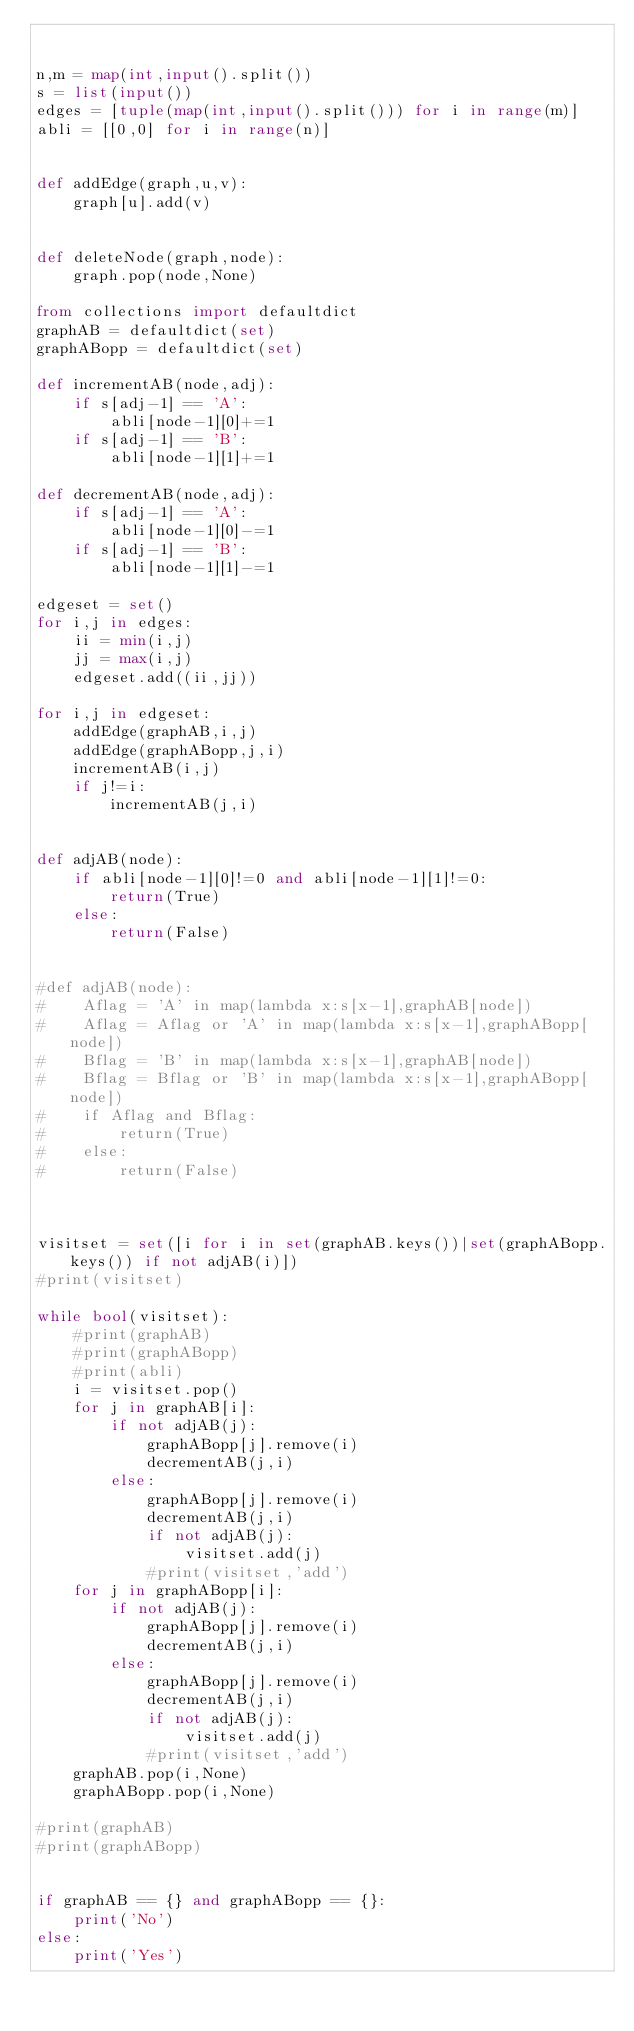Convert code to text. <code><loc_0><loc_0><loc_500><loc_500><_Python_>

n,m = map(int,input().split())
s = list(input())
edges = [tuple(map(int,input().split())) for i in range(m)]
abli = [[0,0] for i in range(n)]


def addEdge(graph,u,v):
    graph[u].add(v)


def deleteNode(graph,node):
    graph.pop(node,None)

from collections import defaultdict
graphAB = defaultdict(set)
graphABopp = defaultdict(set)

def incrementAB(node,adj):
    if s[adj-1] == 'A':
        abli[node-1][0]+=1
    if s[adj-1] == 'B':
        abli[node-1][1]+=1

def decrementAB(node,adj):
    if s[adj-1] == 'A':
        abli[node-1][0]-=1
    if s[adj-1] == 'B':
        abli[node-1][1]-=1

edgeset = set()
for i,j in edges:
    ii = min(i,j)
    jj = max(i,j)
    edgeset.add((ii,jj))

for i,j in edgeset:
    addEdge(graphAB,i,j)
    addEdge(graphABopp,j,i)
    incrementAB(i,j)
    if j!=i:
        incrementAB(j,i)


def adjAB(node):
    if abli[node-1][0]!=0 and abli[node-1][1]!=0:
        return(True)
    else:
        return(False)


#def adjAB(node):
#    Aflag = 'A' in map(lambda x:s[x-1],graphAB[node])
#    Aflag = Aflag or 'A' in map(lambda x:s[x-1],graphABopp[node])
#    Bflag = 'B' in map(lambda x:s[x-1],graphAB[node])
#    Bflag = Bflag or 'B' in map(lambda x:s[x-1],graphABopp[node])
#    if Aflag and Bflag:
#        return(True)
#    else:
#        return(False)



visitset = set([i for i in set(graphAB.keys())|set(graphABopp.keys()) if not adjAB(i)])
#print(visitset)

while bool(visitset):
    #print(graphAB)
    #print(graphABopp)
    #print(abli)
    i = visitset.pop()
    for j in graphAB[i]:
        if not adjAB(j):
            graphABopp[j].remove(i)
            decrementAB(j,i)
        else:
            graphABopp[j].remove(i)
            decrementAB(j,i)
            if not adjAB(j):
                visitset.add(j)
            #print(visitset,'add')
    for j in graphABopp[i]:
        if not adjAB(j):
            graphABopp[j].remove(i)
            decrementAB(j,i)
        else:
            graphABopp[j].remove(i)
            decrementAB(j,i)
            if not adjAB(j):
                visitset.add(j)
            #print(visitset,'add')
    graphAB.pop(i,None)
    graphABopp.pop(i,None)

#print(graphAB)
#print(graphABopp)


if graphAB == {} and graphABopp == {}:
    print('No')
else:
    print('Yes')



</code> 